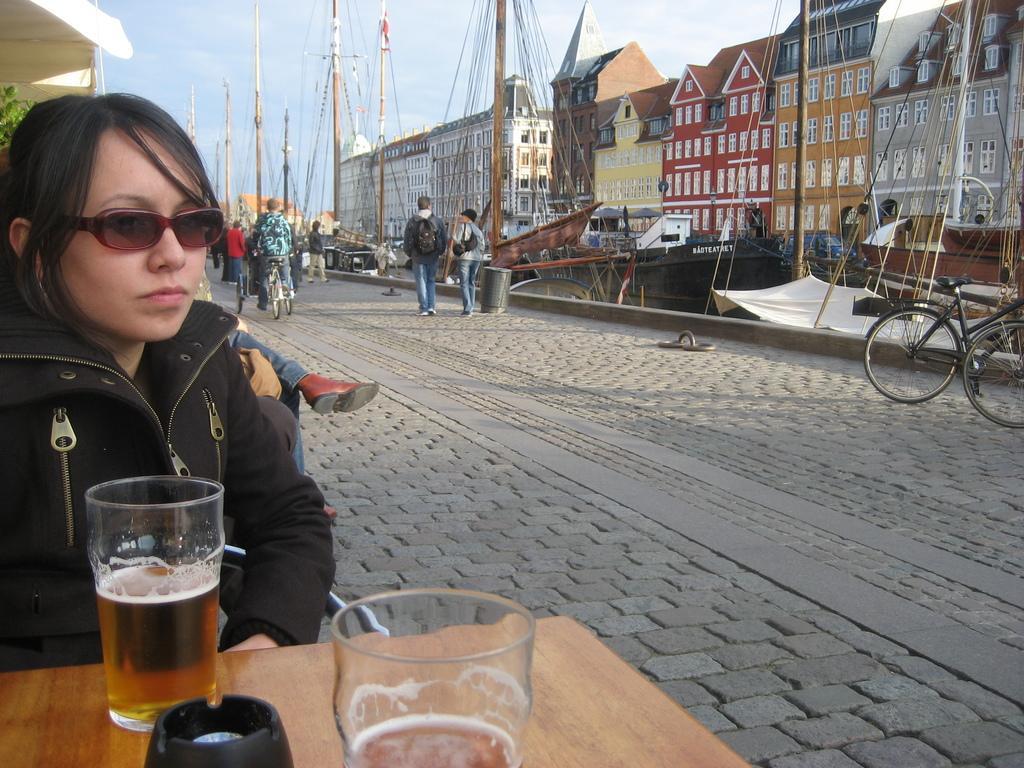How would you summarize this image in a sentence or two? On the left side, we see the woman in the black jacket is sitting on the chair. In front of her, we see a table on which glasses containing liquid are placed. At the bottom, we see the pavement. Here, we see people are walking on the road. Beside them, we see the man is riding the bicycle. On the right side, we see a bicycle. Beside that, we see buildings and yachts. At the top, we see the sky. In the left top, we see a building and a tree. 